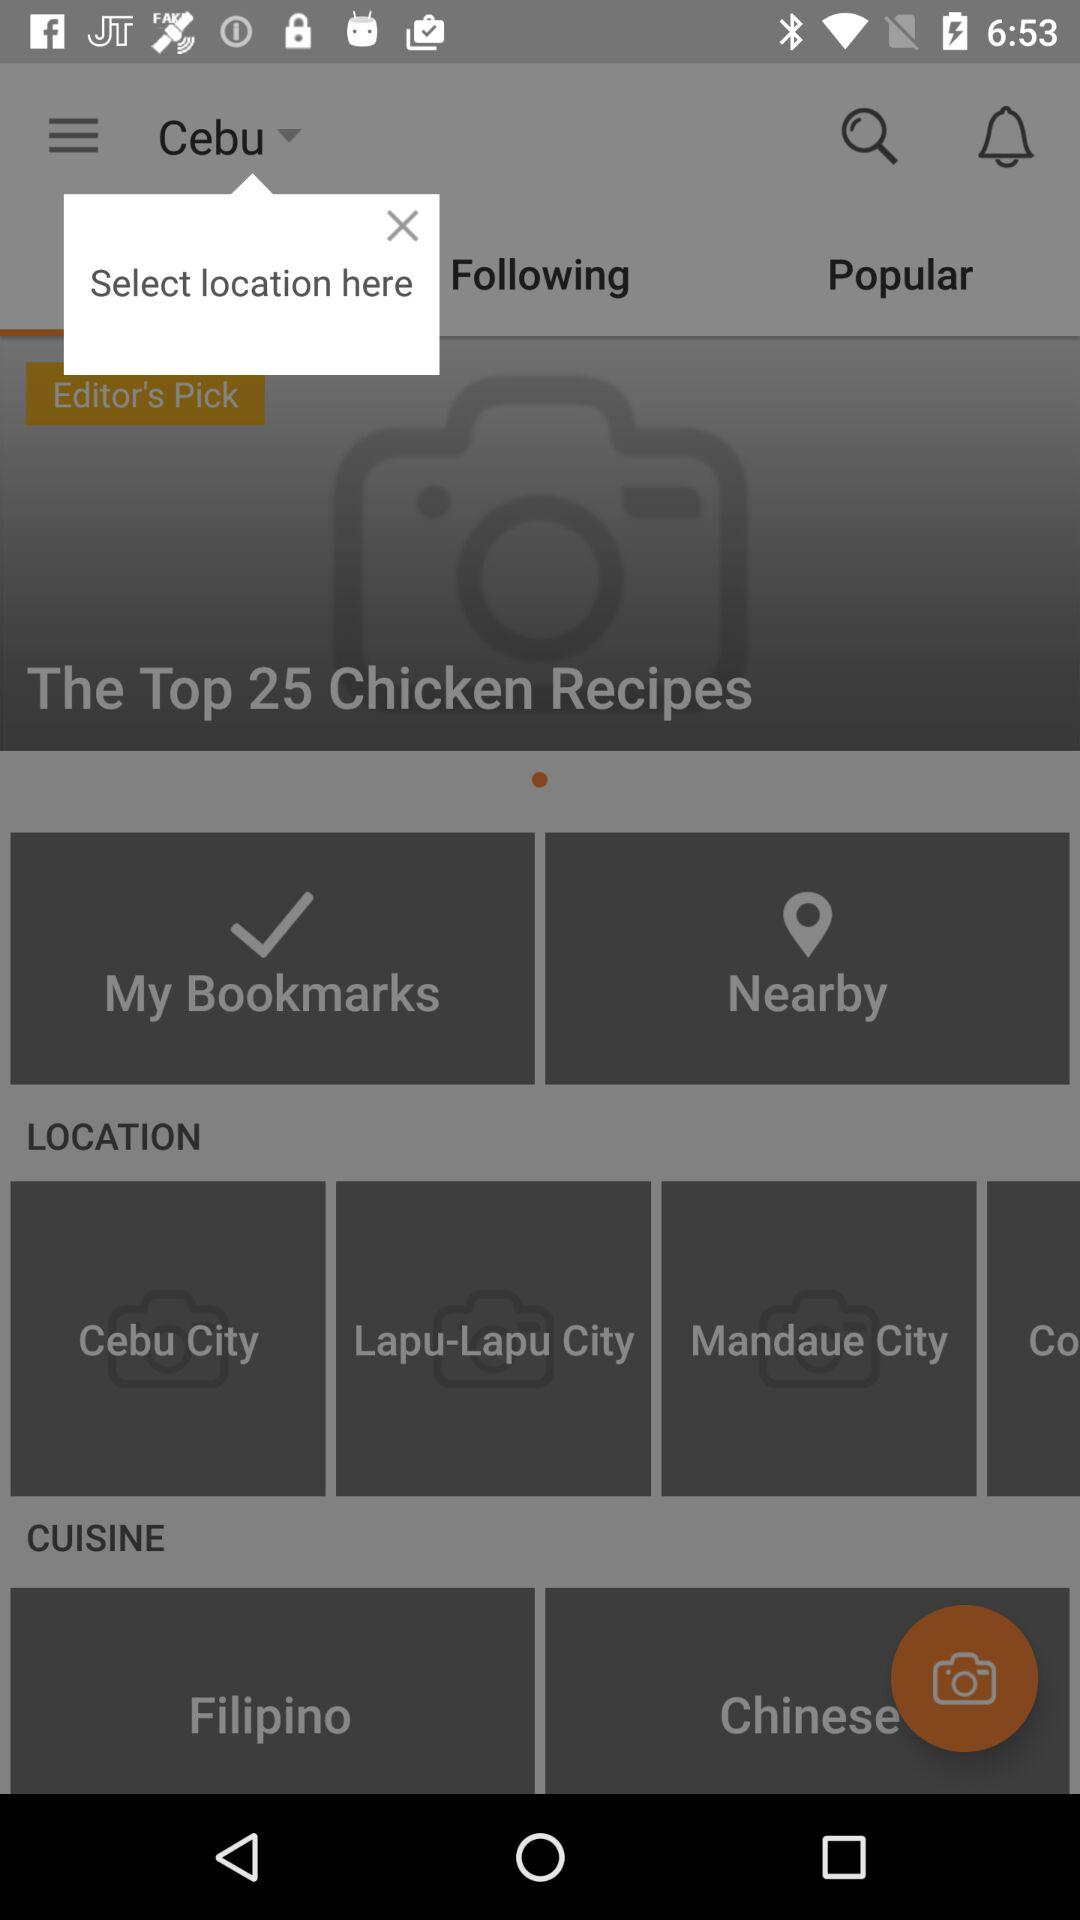What is the selected location? The selected location is Cebu. 